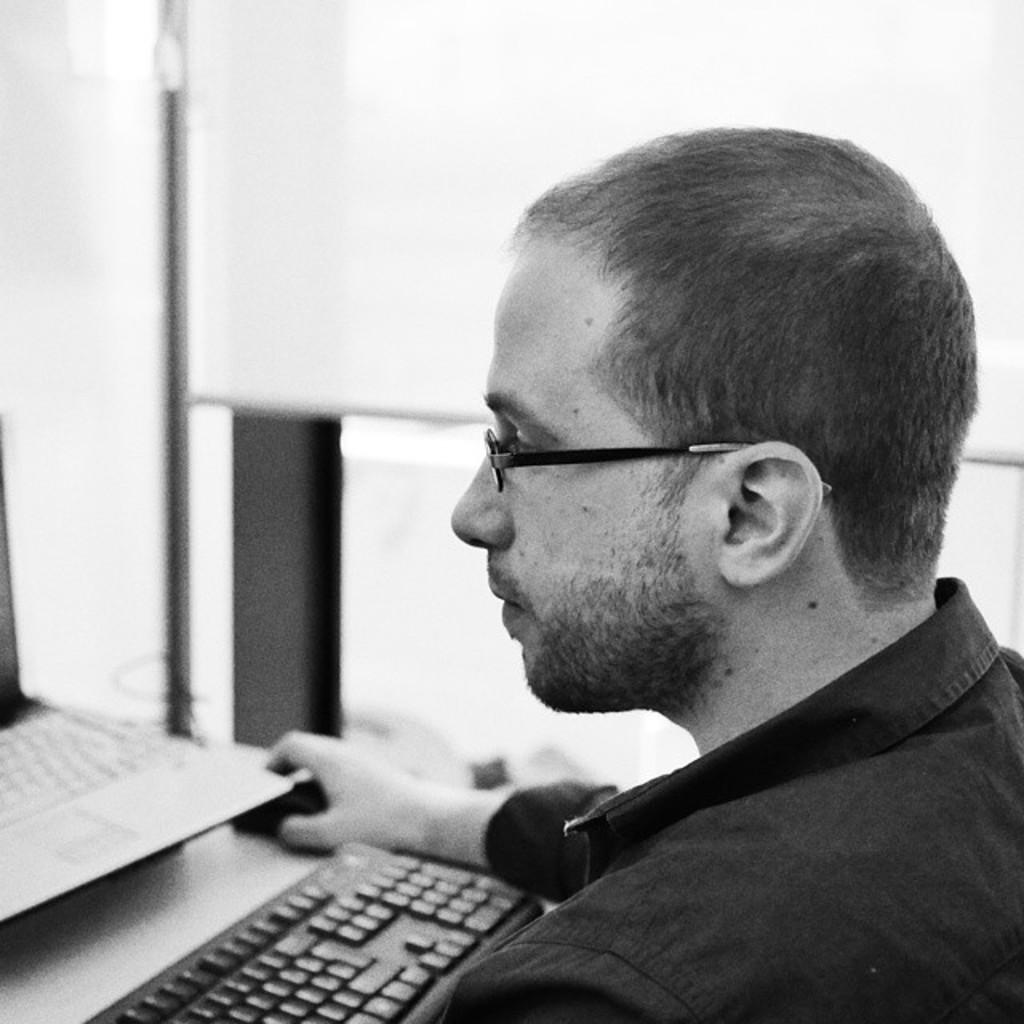What is the color scheme of the image? The image is black and white. Who is present in the image? There is a man in the image. What is the man doing in the image? The man is looking at a laptop and holding a mouse. What is in front of the man? There is a keyboard in front of the man. Can you see any clouds in the image? There are no clouds present in the image, as it is a black and white image of a man using a laptop. 